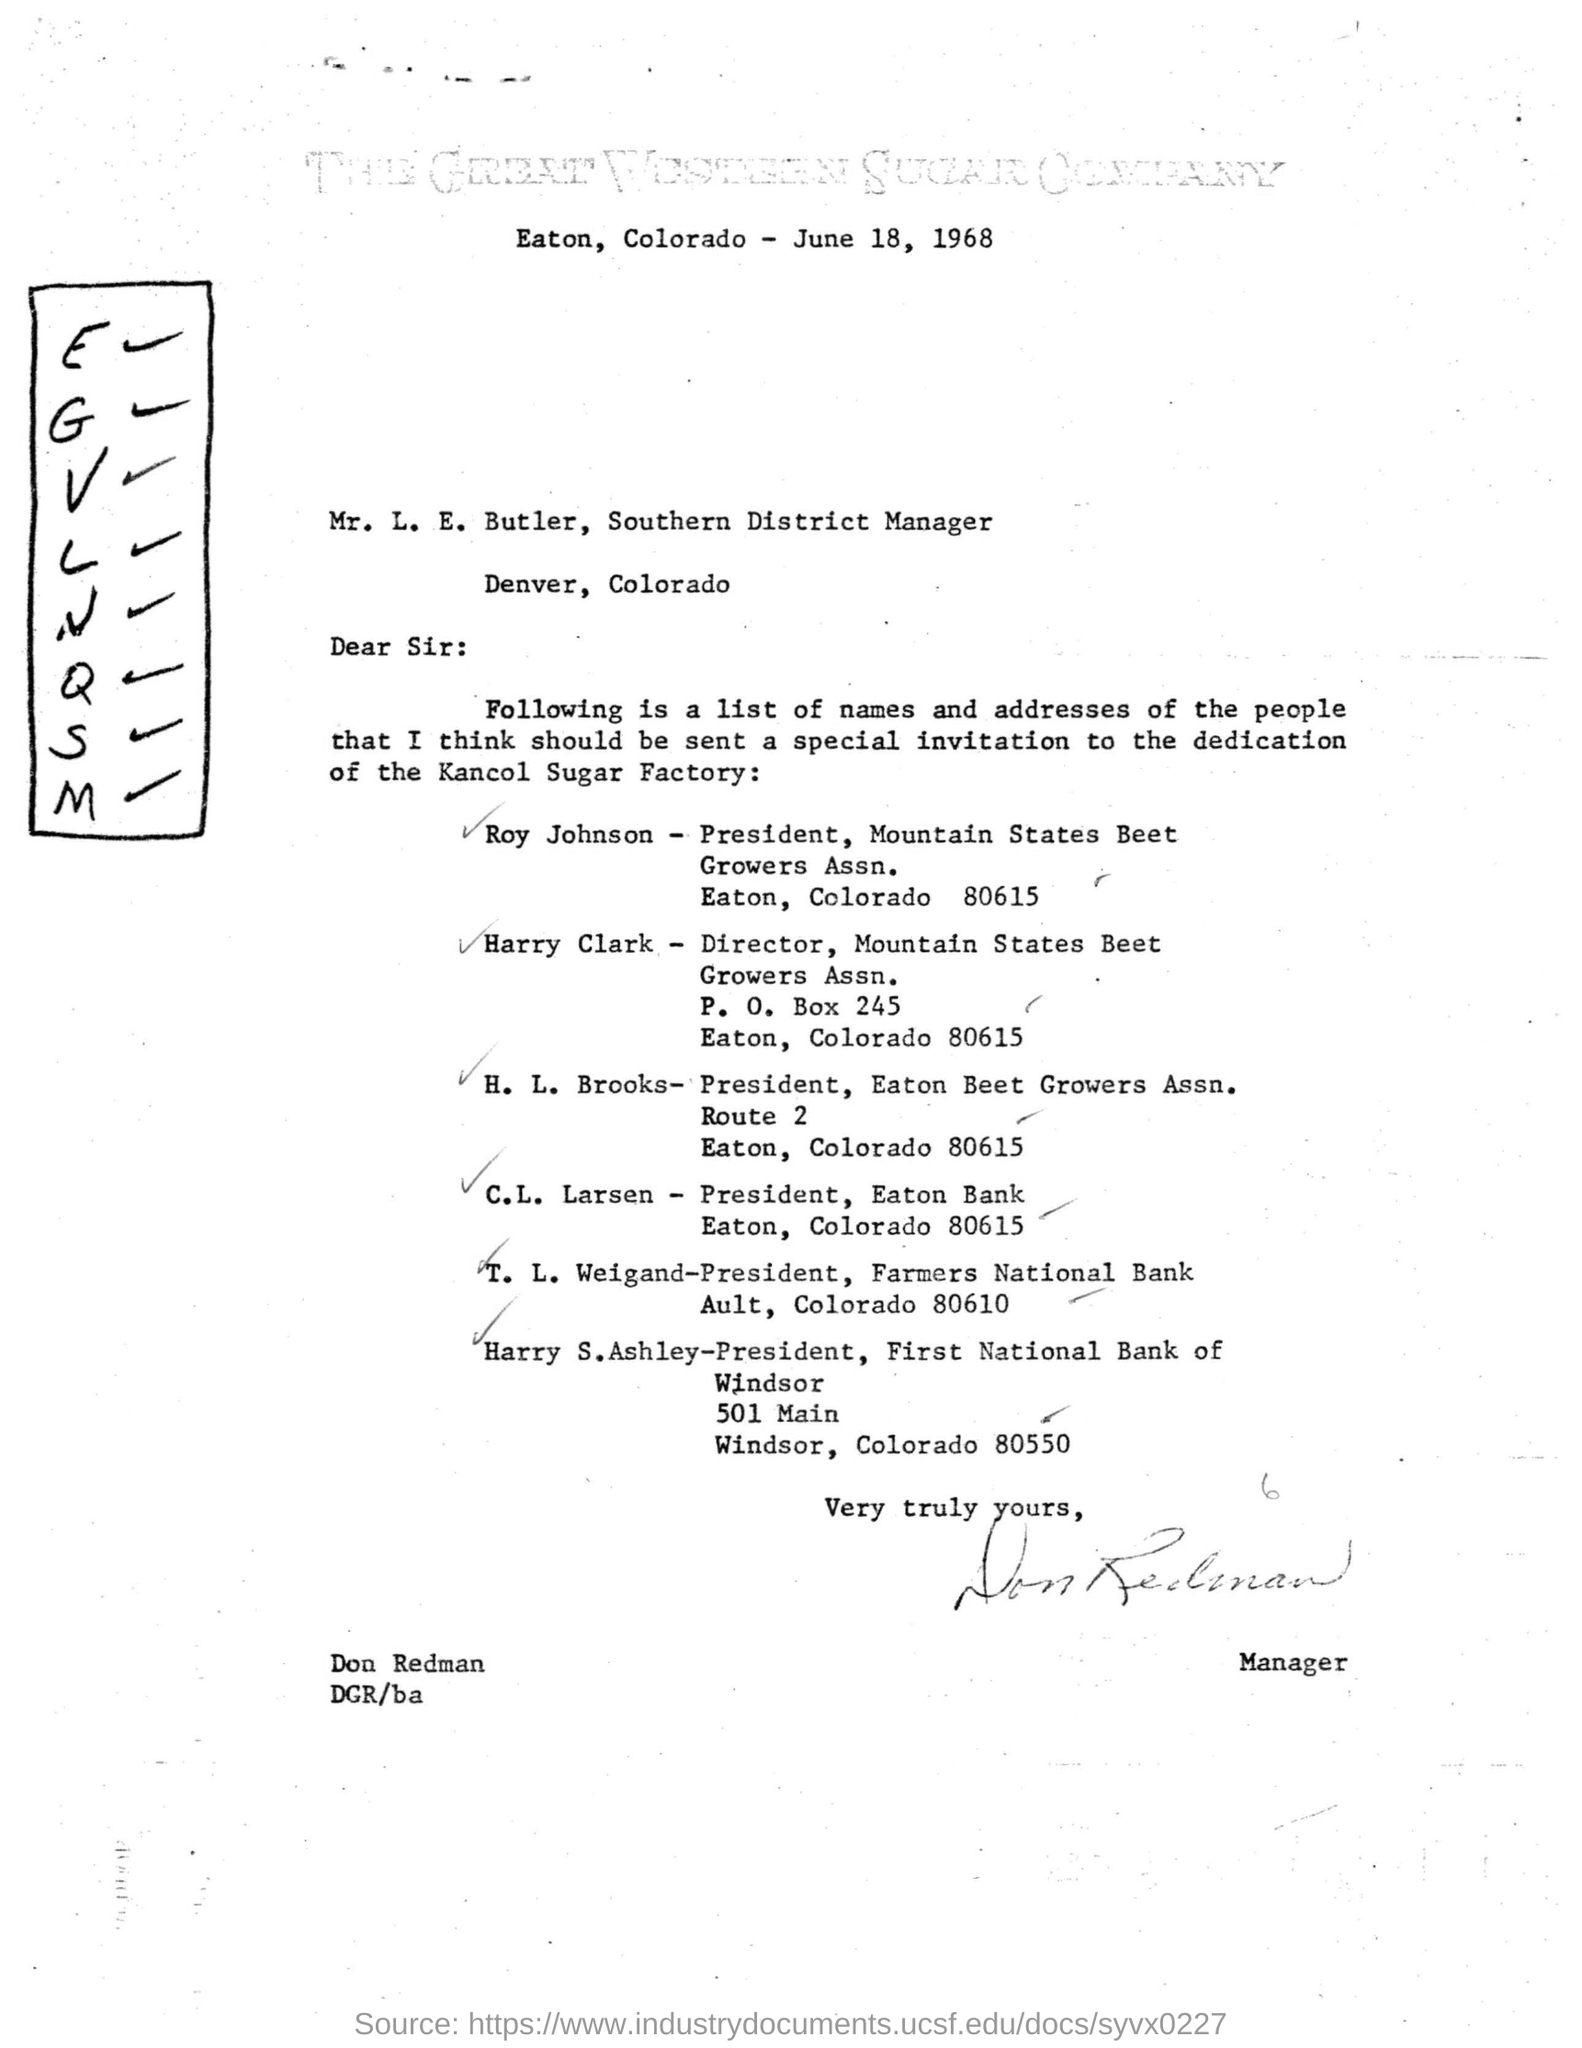What is the letter dated?
Give a very brief answer. June 18, 1968. Who is Harry Clark?
Give a very brief answer. Director, Mountain States Beet Growers Assn. Who is the President of Mountain States Beet Growers Assn.  , Eaton , Colorado?
Offer a terse response. Roy Johnson. 